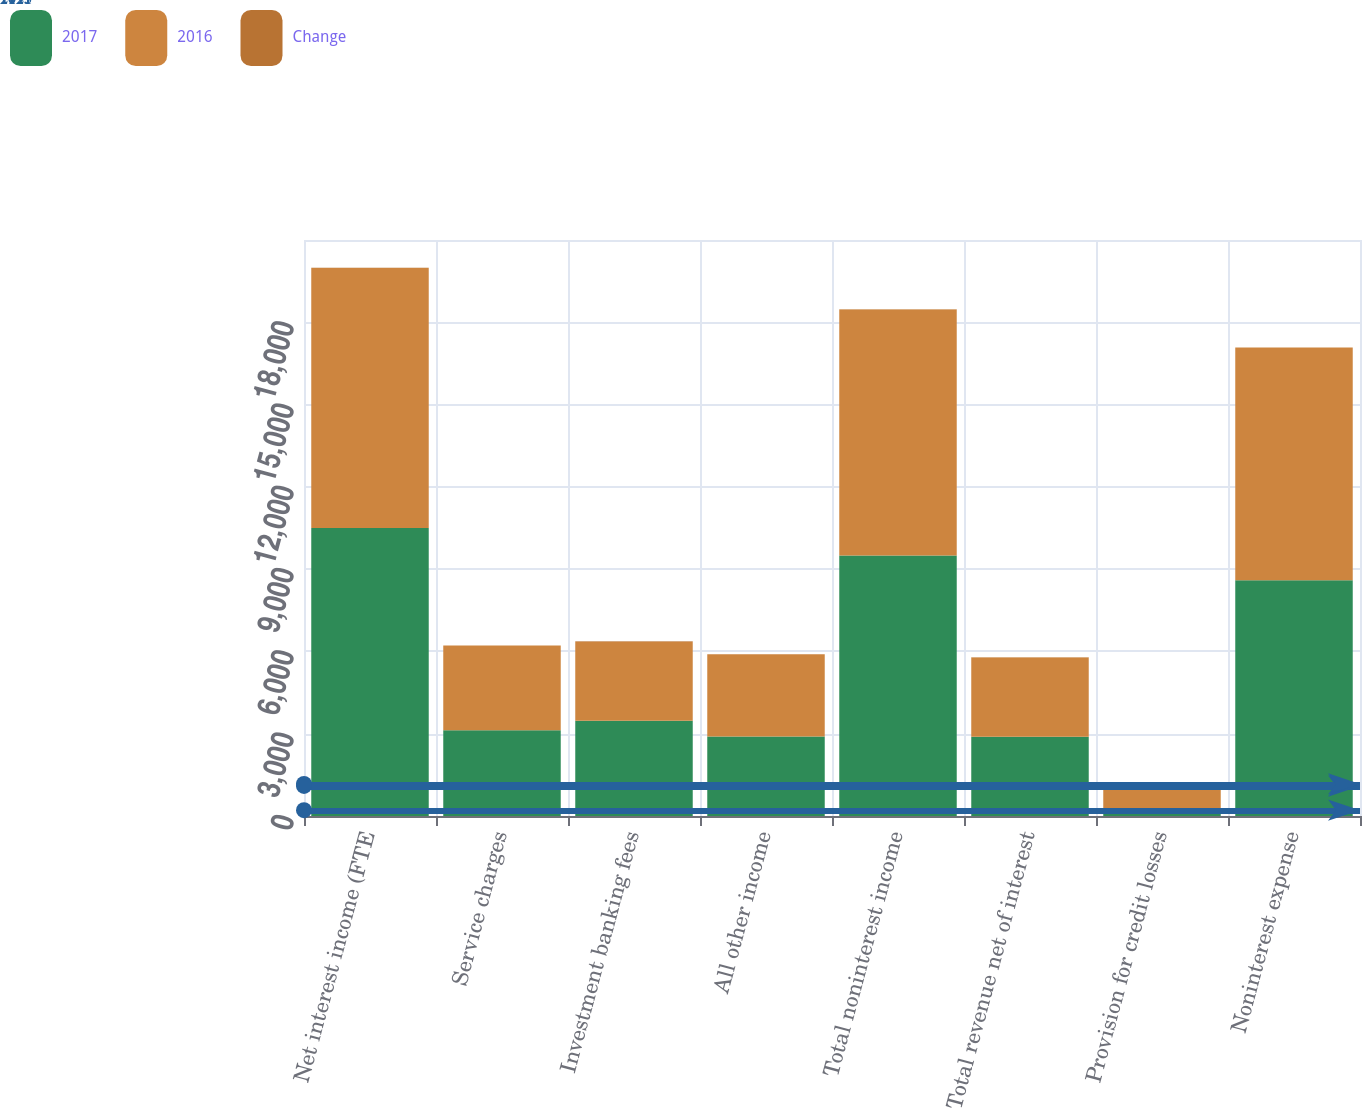Convert chart to OTSL. <chart><loc_0><loc_0><loc_500><loc_500><stacked_bar_chart><ecel><fcel>Net interest income (FTE<fcel>Service charges<fcel>Investment banking fees<fcel>All other income<fcel>Total noninterest income<fcel>Total revenue net of interest<fcel>Provision for credit losses<fcel>Noninterest expense<nl><fcel>2017<fcel>10504<fcel>3125<fcel>3471<fcel>2899<fcel>9495<fcel>2891.5<fcel>212<fcel>8596<nl><fcel>2016<fcel>9471<fcel>3094<fcel>2884<fcel>2996<fcel>8974<fcel>2891.5<fcel>883<fcel>8486<nl><fcel>Change<fcel>11<fcel>1<fcel>20<fcel>3<fcel>6<fcel>8<fcel>76<fcel>1<nl></chart> 